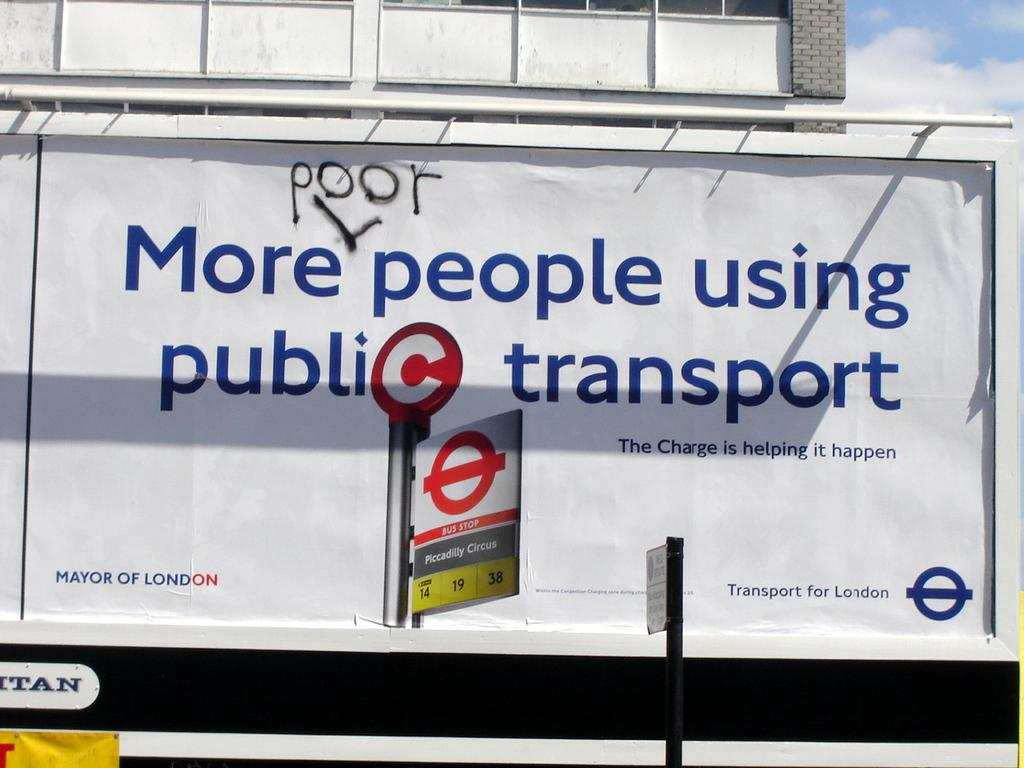<image>
Give a short and clear explanation of the subsequent image. A billboard encouraging people to ride public transportation has been defaced with the word "poor". 